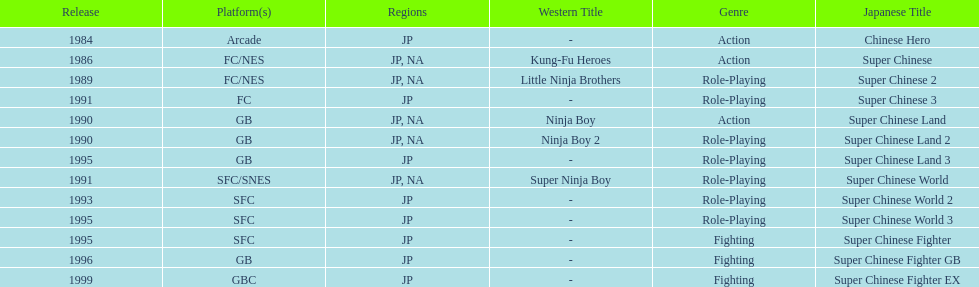Parse the full table. {'header': ['Release', 'Platform(s)', 'Regions', 'Western Title', 'Genre', 'Japanese Title'], 'rows': [['1984', 'Arcade', 'JP', '-', 'Action', 'Chinese Hero'], ['1986', 'FC/NES', 'JP, NA', 'Kung-Fu Heroes', 'Action', 'Super Chinese'], ['1989', 'FC/NES', 'JP, NA', 'Little Ninja Brothers', 'Role-Playing', 'Super Chinese 2'], ['1991', 'FC', 'JP', '-', 'Role-Playing', 'Super Chinese 3'], ['1990', 'GB', 'JP, NA', 'Ninja Boy', 'Action', 'Super Chinese Land'], ['1990', 'GB', 'JP, NA', 'Ninja Boy 2', 'Role-Playing', 'Super Chinese Land 2'], ['1995', 'GB', 'JP', '-', 'Role-Playing', 'Super Chinese Land 3'], ['1991', 'SFC/SNES', 'JP, NA', 'Super Ninja Boy', 'Role-Playing', 'Super Chinese World'], ['1993', 'SFC', 'JP', '-', 'Role-Playing', 'Super Chinese World 2'], ['1995', 'SFC', 'JP', '-', 'Role-Playing', 'Super Chinese World 3'], ['1995', 'SFC', 'JP', '-', 'Fighting', 'Super Chinese Fighter'], ['1996', 'GB', 'JP', '-', 'Fighting', 'Super Chinese Fighter GB'], ['1999', 'GBC', 'JP', '-', 'Fighting', 'Super Chinese Fighter EX']]} What are the total of super chinese games released? 13. 